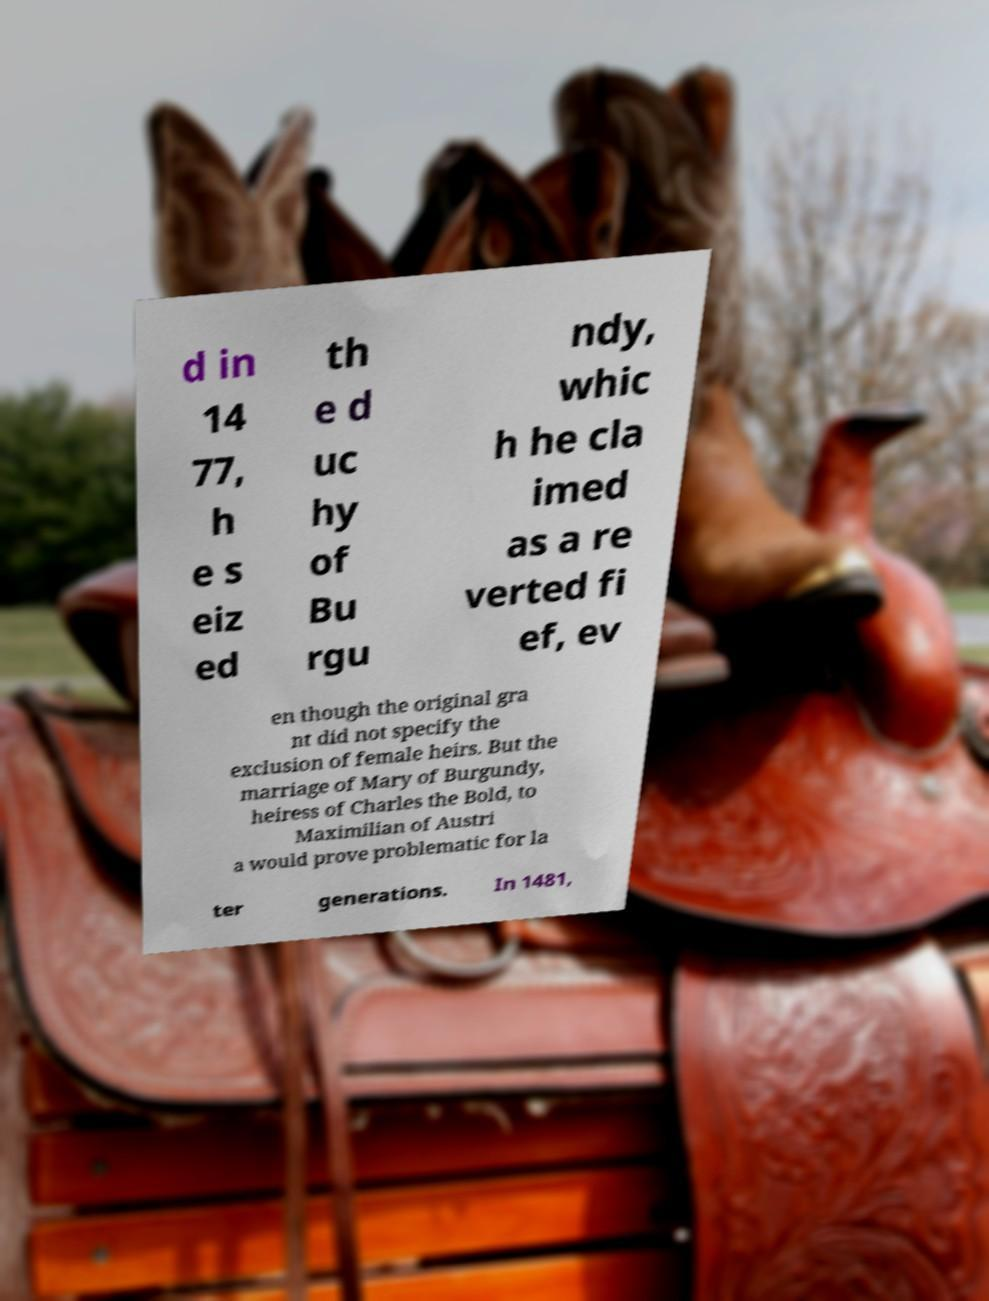What messages or text are displayed in this image? I need them in a readable, typed format. d in 14 77, h e s eiz ed th e d uc hy of Bu rgu ndy, whic h he cla imed as a re verted fi ef, ev en though the original gra nt did not specify the exclusion of female heirs. But the marriage of Mary of Burgundy, heiress of Charles the Bold, to Maximilian of Austri a would prove problematic for la ter generations. In 1481, 